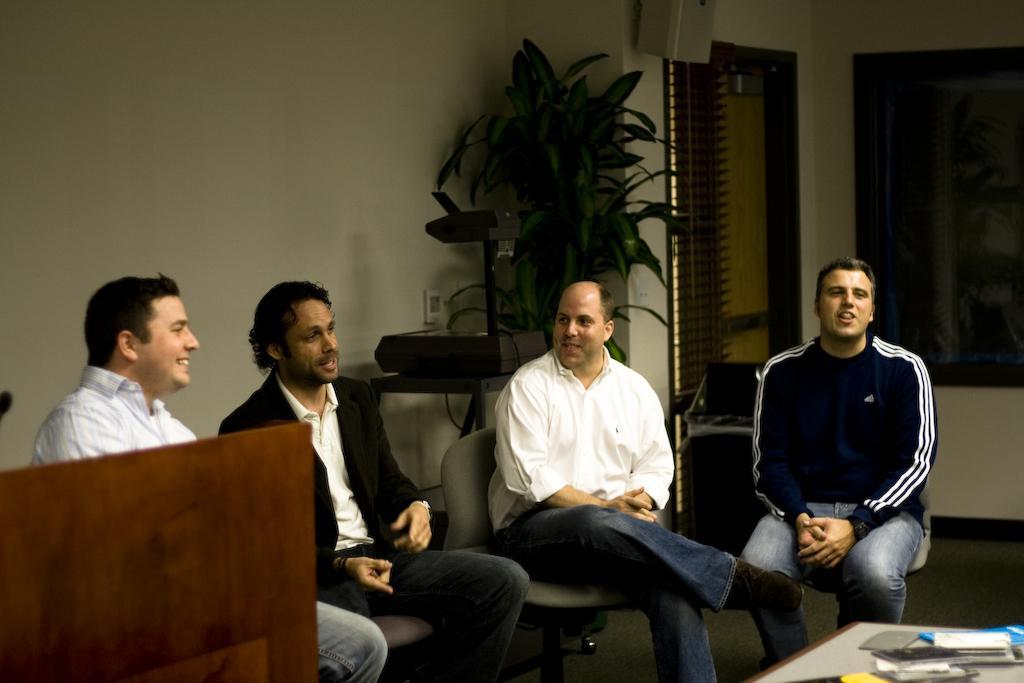Can you describe this image briefly? Four men are sitting in chairs and talking. 